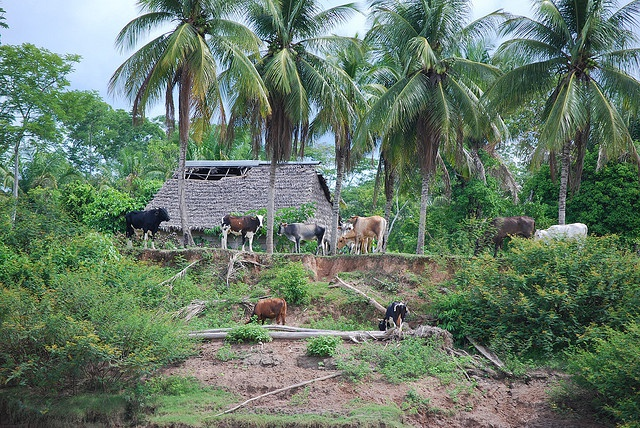Describe the objects in this image and their specific colors. I can see cow in lavender, gray, black, and darkgreen tones, cow in lavender, darkgray, gray, and lightgray tones, cow in lavender, black, navy, gray, and darkgray tones, cow in lavender, black, gray, lightgray, and darkgray tones, and cow in lavender, gray, darkgray, black, and lightgray tones in this image. 